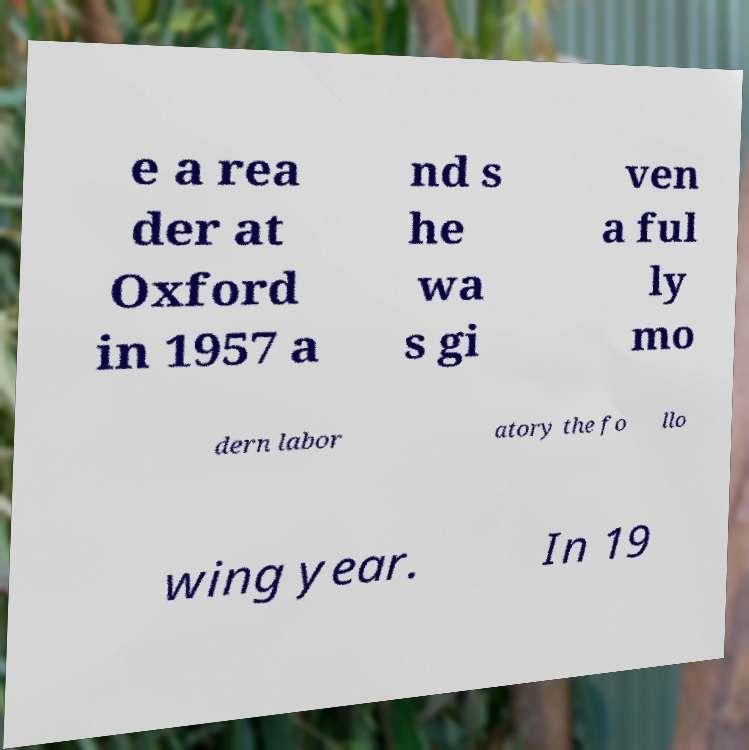What messages or text are displayed in this image? I need them in a readable, typed format. e a rea der at Oxford in 1957 a nd s he wa s gi ven a ful ly mo dern labor atory the fo llo wing year. In 19 